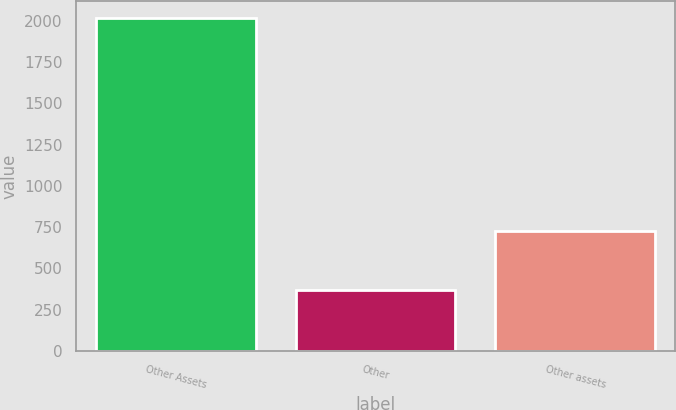Convert chart to OTSL. <chart><loc_0><loc_0><loc_500><loc_500><bar_chart><fcel>Other Assets<fcel>Other<fcel>Other assets<nl><fcel>2018<fcel>369<fcel>724<nl></chart> 